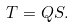Convert formula to latex. <formula><loc_0><loc_0><loc_500><loc_500>T = Q S .</formula> 